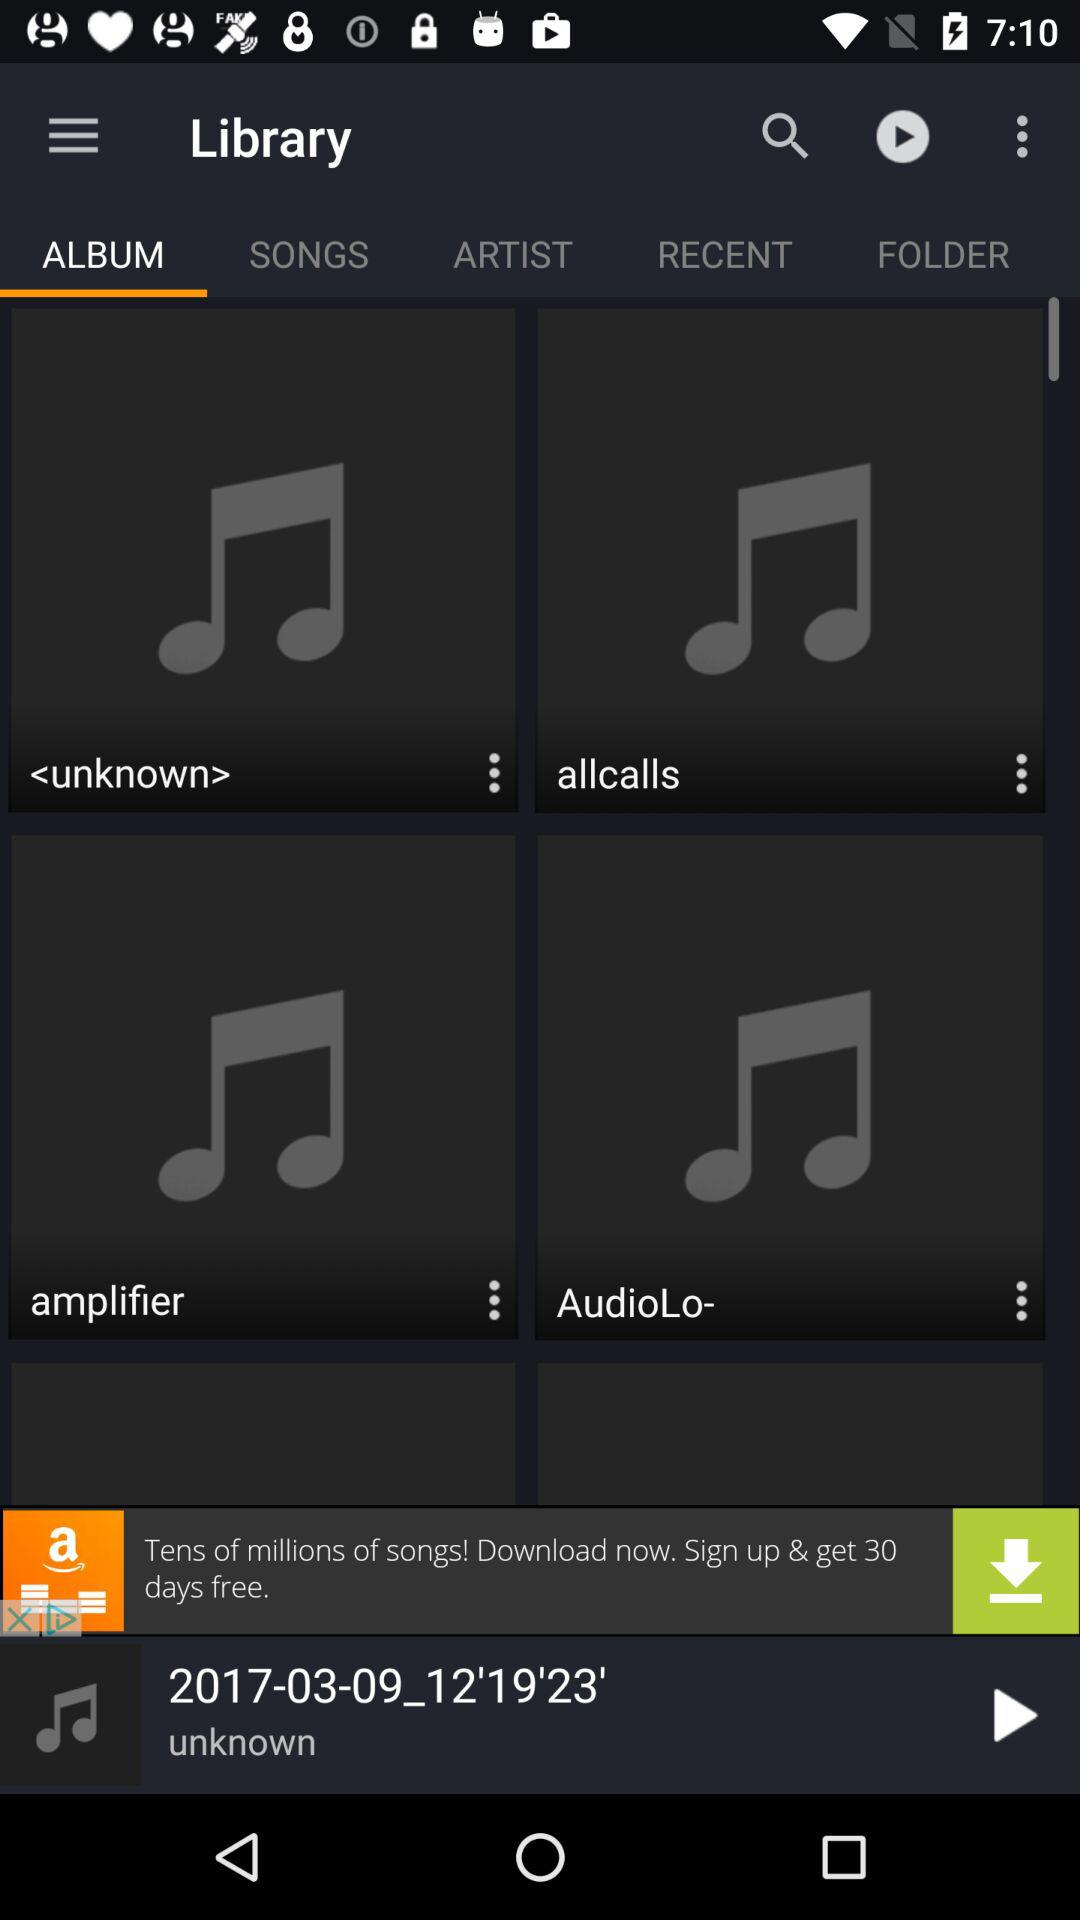Which option is selected? The selected option is "ALBUM". 